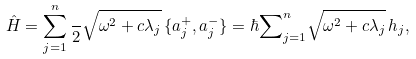Convert formula to latex. <formula><loc_0><loc_0><loc_500><loc_500>\hat { H } = \sum _ { j = 1 } ^ { n } \frac { } { 2 } \sqrt { \omega ^ { 2 } + c \lambda _ { j } } \, \{ a _ { j } ^ { + } , a _ { j } ^ { - } \} = \hbar { \sum } _ { j = 1 } ^ { n } \sqrt { \omega ^ { 2 } + c \lambda _ { j } } \, h _ { j } ,</formula> 